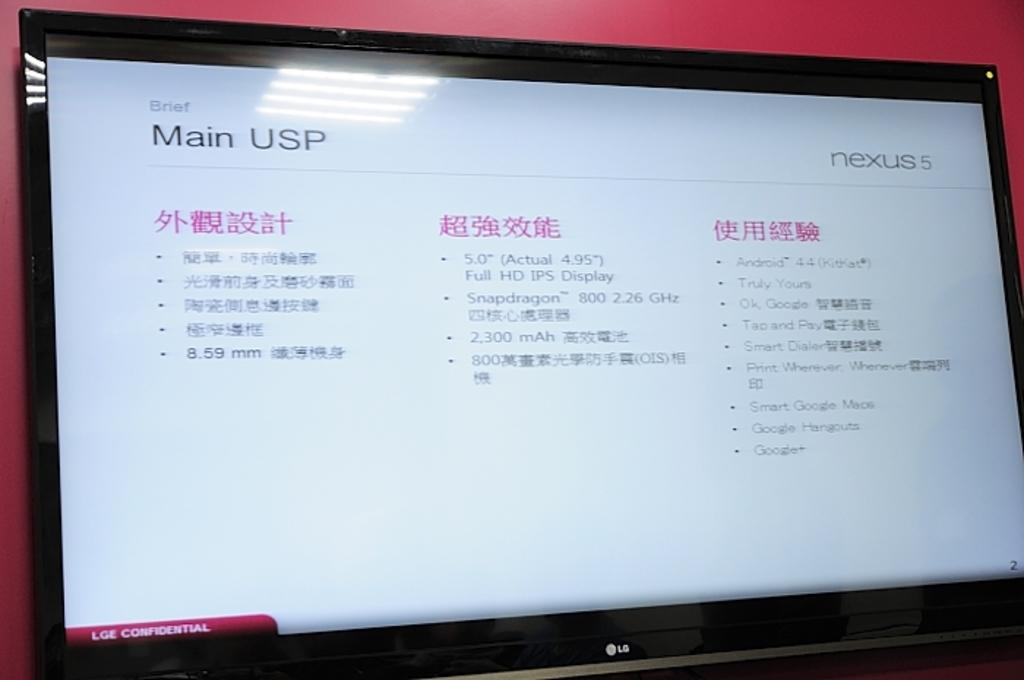<image>
Summarize the visual content of the image. The website has the title Main USP on the screen 